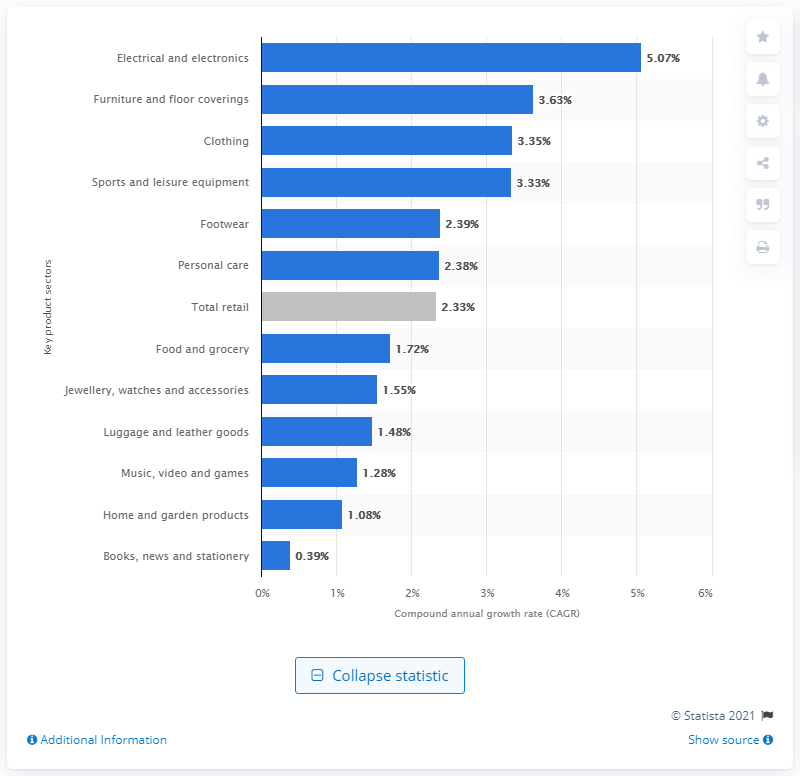Draw attention to some important aspects in this diagram. The electrical and electronics sector is expected to experience a growth rate of 5.07% between 2013 and 2016. 